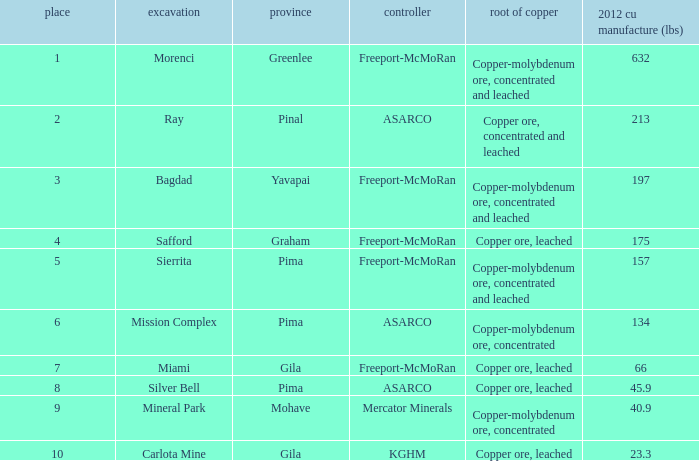Which operator has a rank of 7? Freeport-McMoRan. 